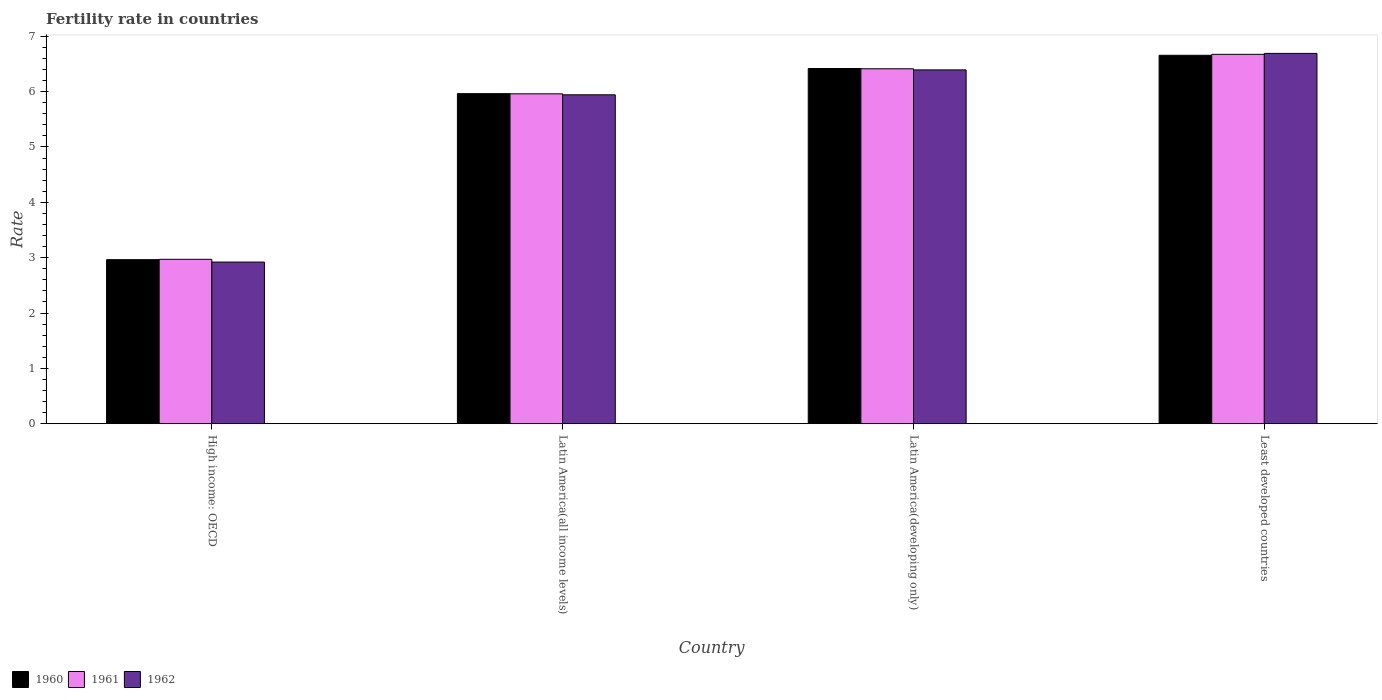How many different coloured bars are there?
Provide a succinct answer. 3. How many groups of bars are there?
Your answer should be very brief. 4. Are the number of bars per tick equal to the number of legend labels?
Keep it short and to the point. Yes. Are the number of bars on each tick of the X-axis equal?
Offer a terse response. Yes. How many bars are there on the 4th tick from the left?
Provide a short and direct response. 3. What is the label of the 1st group of bars from the left?
Ensure brevity in your answer.  High income: OECD. In how many cases, is the number of bars for a given country not equal to the number of legend labels?
Your response must be concise. 0. What is the fertility rate in 1962 in Latin America(all income levels)?
Give a very brief answer. 5.94. Across all countries, what is the maximum fertility rate in 1961?
Offer a very short reply. 6.67. Across all countries, what is the minimum fertility rate in 1962?
Your answer should be compact. 2.92. In which country was the fertility rate in 1960 maximum?
Provide a succinct answer. Least developed countries. In which country was the fertility rate in 1962 minimum?
Offer a very short reply. High income: OECD. What is the total fertility rate in 1961 in the graph?
Ensure brevity in your answer.  22.02. What is the difference between the fertility rate in 1960 in Latin America(developing only) and that in Least developed countries?
Make the answer very short. -0.24. What is the difference between the fertility rate in 1961 in Least developed countries and the fertility rate in 1960 in Latin America(developing only)?
Your response must be concise. 0.26. What is the average fertility rate in 1961 per country?
Keep it short and to the point. 5.5. What is the difference between the fertility rate of/in 1960 and fertility rate of/in 1961 in Least developed countries?
Make the answer very short. -0.02. What is the ratio of the fertility rate in 1961 in Latin America(developing only) to that in Least developed countries?
Offer a very short reply. 0.96. Is the difference between the fertility rate in 1960 in Latin America(all income levels) and Latin America(developing only) greater than the difference between the fertility rate in 1961 in Latin America(all income levels) and Latin America(developing only)?
Give a very brief answer. No. What is the difference between the highest and the second highest fertility rate in 1960?
Offer a very short reply. -0.69. What is the difference between the highest and the lowest fertility rate in 1962?
Your answer should be compact. 3.77. In how many countries, is the fertility rate in 1962 greater than the average fertility rate in 1962 taken over all countries?
Offer a very short reply. 3. What does the 2nd bar from the right in Least developed countries represents?
Your answer should be compact. 1961. Are all the bars in the graph horizontal?
Offer a terse response. No. What is the difference between two consecutive major ticks on the Y-axis?
Your answer should be compact. 1. Are the values on the major ticks of Y-axis written in scientific E-notation?
Offer a terse response. No. Does the graph contain any zero values?
Provide a succinct answer. No. Where does the legend appear in the graph?
Provide a short and direct response. Bottom left. How many legend labels are there?
Offer a very short reply. 3. What is the title of the graph?
Your answer should be compact. Fertility rate in countries. What is the label or title of the X-axis?
Make the answer very short. Country. What is the label or title of the Y-axis?
Your response must be concise. Rate. What is the Rate in 1960 in High income: OECD?
Your response must be concise. 2.96. What is the Rate of 1961 in High income: OECD?
Provide a short and direct response. 2.97. What is the Rate in 1962 in High income: OECD?
Offer a terse response. 2.92. What is the Rate of 1960 in Latin America(all income levels)?
Keep it short and to the point. 5.96. What is the Rate of 1961 in Latin America(all income levels)?
Offer a terse response. 5.96. What is the Rate in 1962 in Latin America(all income levels)?
Your answer should be compact. 5.94. What is the Rate of 1960 in Latin America(developing only)?
Offer a terse response. 6.42. What is the Rate of 1961 in Latin America(developing only)?
Your response must be concise. 6.41. What is the Rate of 1962 in Latin America(developing only)?
Provide a short and direct response. 6.39. What is the Rate of 1960 in Least developed countries?
Your answer should be very brief. 6.66. What is the Rate in 1961 in Least developed countries?
Your answer should be compact. 6.67. What is the Rate in 1962 in Least developed countries?
Your response must be concise. 6.69. Across all countries, what is the maximum Rate in 1960?
Provide a short and direct response. 6.66. Across all countries, what is the maximum Rate in 1961?
Your response must be concise. 6.67. Across all countries, what is the maximum Rate in 1962?
Make the answer very short. 6.69. Across all countries, what is the minimum Rate in 1960?
Give a very brief answer. 2.96. Across all countries, what is the minimum Rate of 1961?
Your answer should be compact. 2.97. Across all countries, what is the minimum Rate of 1962?
Offer a very short reply. 2.92. What is the total Rate of 1960 in the graph?
Offer a very short reply. 22. What is the total Rate of 1961 in the graph?
Your answer should be very brief. 22.02. What is the total Rate of 1962 in the graph?
Make the answer very short. 21.95. What is the difference between the Rate of 1960 in High income: OECD and that in Latin America(all income levels)?
Ensure brevity in your answer.  -3. What is the difference between the Rate in 1961 in High income: OECD and that in Latin America(all income levels)?
Your answer should be compact. -2.99. What is the difference between the Rate in 1962 in High income: OECD and that in Latin America(all income levels)?
Your answer should be compact. -3.02. What is the difference between the Rate in 1960 in High income: OECD and that in Latin America(developing only)?
Ensure brevity in your answer.  -3.45. What is the difference between the Rate of 1961 in High income: OECD and that in Latin America(developing only)?
Your answer should be compact. -3.44. What is the difference between the Rate in 1962 in High income: OECD and that in Latin America(developing only)?
Provide a short and direct response. -3.47. What is the difference between the Rate of 1960 in High income: OECD and that in Least developed countries?
Offer a very short reply. -3.69. What is the difference between the Rate of 1961 in High income: OECD and that in Least developed countries?
Provide a short and direct response. -3.7. What is the difference between the Rate of 1962 in High income: OECD and that in Least developed countries?
Keep it short and to the point. -3.77. What is the difference between the Rate of 1960 in Latin America(all income levels) and that in Latin America(developing only)?
Provide a short and direct response. -0.45. What is the difference between the Rate in 1961 in Latin America(all income levels) and that in Latin America(developing only)?
Keep it short and to the point. -0.45. What is the difference between the Rate of 1962 in Latin America(all income levels) and that in Latin America(developing only)?
Give a very brief answer. -0.45. What is the difference between the Rate of 1960 in Latin America(all income levels) and that in Least developed countries?
Offer a very short reply. -0.69. What is the difference between the Rate in 1961 in Latin America(all income levels) and that in Least developed countries?
Provide a succinct answer. -0.71. What is the difference between the Rate in 1962 in Latin America(all income levels) and that in Least developed countries?
Make the answer very short. -0.75. What is the difference between the Rate of 1960 in Latin America(developing only) and that in Least developed countries?
Offer a very short reply. -0.24. What is the difference between the Rate in 1961 in Latin America(developing only) and that in Least developed countries?
Provide a short and direct response. -0.26. What is the difference between the Rate in 1962 in Latin America(developing only) and that in Least developed countries?
Provide a short and direct response. -0.3. What is the difference between the Rate in 1960 in High income: OECD and the Rate in 1961 in Latin America(all income levels)?
Provide a succinct answer. -3. What is the difference between the Rate in 1960 in High income: OECD and the Rate in 1962 in Latin America(all income levels)?
Keep it short and to the point. -2.98. What is the difference between the Rate in 1961 in High income: OECD and the Rate in 1962 in Latin America(all income levels)?
Give a very brief answer. -2.97. What is the difference between the Rate in 1960 in High income: OECD and the Rate in 1961 in Latin America(developing only)?
Give a very brief answer. -3.45. What is the difference between the Rate in 1960 in High income: OECD and the Rate in 1962 in Latin America(developing only)?
Give a very brief answer. -3.43. What is the difference between the Rate in 1961 in High income: OECD and the Rate in 1962 in Latin America(developing only)?
Offer a very short reply. -3.42. What is the difference between the Rate of 1960 in High income: OECD and the Rate of 1961 in Least developed countries?
Your answer should be compact. -3.71. What is the difference between the Rate of 1960 in High income: OECD and the Rate of 1962 in Least developed countries?
Your answer should be very brief. -3.73. What is the difference between the Rate in 1961 in High income: OECD and the Rate in 1962 in Least developed countries?
Keep it short and to the point. -3.72. What is the difference between the Rate of 1960 in Latin America(all income levels) and the Rate of 1961 in Latin America(developing only)?
Your answer should be very brief. -0.45. What is the difference between the Rate of 1960 in Latin America(all income levels) and the Rate of 1962 in Latin America(developing only)?
Offer a very short reply. -0.43. What is the difference between the Rate in 1961 in Latin America(all income levels) and the Rate in 1962 in Latin America(developing only)?
Make the answer very short. -0.43. What is the difference between the Rate in 1960 in Latin America(all income levels) and the Rate in 1961 in Least developed countries?
Your response must be concise. -0.71. What is the difference between the Rate in 1960 in Latin America(all income levels) and the Rate in 1962 in Least developed countries?
Offer a terse response. -0.73. What is the difference between the Rate in 1961 in Latin America(all income levels) and the Rate in 1962 in Least developed countries?
Your answer should be compact. -0.73. What is the difference between the Rate in 1960 in Latin America(developing only) and the Rate in 1961 in Least developed countries?
Provide a short and direct response. -0.26. What is the difference between the Rate in 1960 in Latin America(developing only) and the Rate in 1962 in Least developed countries?
Provide a succinct answer. -0.27. What is the difference between the Rate of 1961 in Latin America(developing only) and the Rate of 1962 in Least developed countries?
Give a very brief answer. -0.28. What is the average Rate in 1960 per country?
Give a very brief answer. 5.5. What is the average Rate in 1961 per country?
Offer a very short reply. 5.5. What is the average Rate in 1962 per country?
Offer a very short reply. 5.49. What is the difference between the Rate in 1960 and Rate in 1961 in High income: OECD?
Offer a very short reply. -0.01. What is the difference between the Rate of 1960 and Rate of 1962 in High income: OECD?
Ensure brevity in your answer.  0.04. What is the difference between the Rate in 1961 and Rate in 1962 in High income: OECD?
Provide a succinct answer. 0.05. What is the difference between the Rate of 1960 and Rate of 1961 in Latin America(all income levels)?
Make the answer very short. 0. What is the difference between the Rate in 1960 and Rate in 1962 in Latin America(all income levels)?
Your answer should be compact. 0.02. What is the difference between the Rate of 1961 and Rate of 1962 in Latin America(all income levels)?
Your answer should be compact. 0.02. What is the difference between the Rate in 1960 and Rate in 1961 in Latin America(developing only)?
Your answer should be compact. 0.01. What is the difference between the Rate in 1960 and Rate in 1962 in Latin America(developing only)?
Your response must be concise. 0.03. What is the difference between the Rate in 1961 and Rate in 1962 in Latin America(developing only)?
Provide a succinct answer. 0.02. What is the difference between the Rate of 1960 and Rate of 1961 in Least developed countries?
Offer a very short reply. -0.02. What is the difference between the Rate in 1960 and Rate in 1962 in Least developed countries?
Your response must be concise. -0.03. What is the difference between the Rate of 1961 and Rate of 1962 in Least developed countries?
Offer a terse response. -0.02. What is the ratio of the Rate of 1960 in High income: OECD to that in Latin America(all income levels)?
Give a very brief answer. 0.5. What is the ratio of the Rate of 1961 in High income: OECD to that in Latin America(all income levels)?
Keep it short and to the point. 0.5. What is the ratio of the Rate of 1962 in High income: OECD to that in Latin America(all income levels)?
Make the answer very short. 0.49. What is the ratio of the Rate of 1960 in High income: OECD to that in Latin America(developing only)?
Offer a very short reply. 0.46. What is the ratio of the Rate in 1961 in High income: OECD to that in Latin America(developing only)?
Give a very brief answer. 0.46. What is the ratio of the Rate in 1962 in High income: OECD to that in Latin America(developing only)?
Provide a short and direct response. 0.46. What is the ratio of the Rate of 1960 in High income: OECD to that in Least developed countries?
Keep it short and to the point. 0.45. What is the ratio of the Rate of 1961 in High income: OECD to that in Least developed countries?
Offer a terse response. 0.45. What is the ratio of the Rate of 1962 in High income: OECD to that in Least developed countries?
Ensure brevity in your answer.  0.44. What is the ratio of the Rate of 1960 in Latin America(all income levels) to that in Latin America(developing only)?
Your answer should be very brief. 0.93. What is the ratio of the Rate of 1961 in Latin America(all income levels) to that in Latin America(developing only)?
Provide a short and direct response. 0.93. What is the ratio of the Rate of 1962 in Latin America(all income levels) to that in Latin America(developing only)?
Provide a succinct answer. 0.93. What is the ratio of the Rate in 1960 in Latin America(all income levels) to that in Least developed countries?
Keep it short and to the point. 0.9. What is the ratio of the Rate in 1961 in Latin America(all income levels) to that in Least developed countries?
Your answer should be very brief. 0.89. What is the ratio of the Rate in 1962 in Latin America(all income levels) to that in Least developed countries?
Keep it short and to the point. 0.89. What is the ratio of the Rate of 1960 in Latin America(developing only) to that in Least developed countries?
Provide a short and direct response. 0.96. What is the ratio of the Rate in 1961 in Latin America(developing only) to that in Least developed countries?
Provide a succinct answer. 0.96. What is the ratio of the Rate in 1962 in Latin America(developing only) to that in Least developed countries?
Ensure brevity in your answer.  0.96. What is the difference between the highest and the second highest Rate of 1960?
Give a very brief answer. 0.24. What is the difference between the highest and the second highest Rate of 1961?
Offer a terse response. 0.26. What is the difference between the highest and the second highest Rate in 1962?
Keep it short and to the point. 0.3. What is the difference between the highest and the lowest Rate of 1960?
Make the answer very short. 3.69. What is the difference between the highest and the lowest Rate in 1961?
Provide a short and direct response. 3.7. What is the difference between the highest and the lowest Rate of 1962?
Make the answer very short. 3.77. 